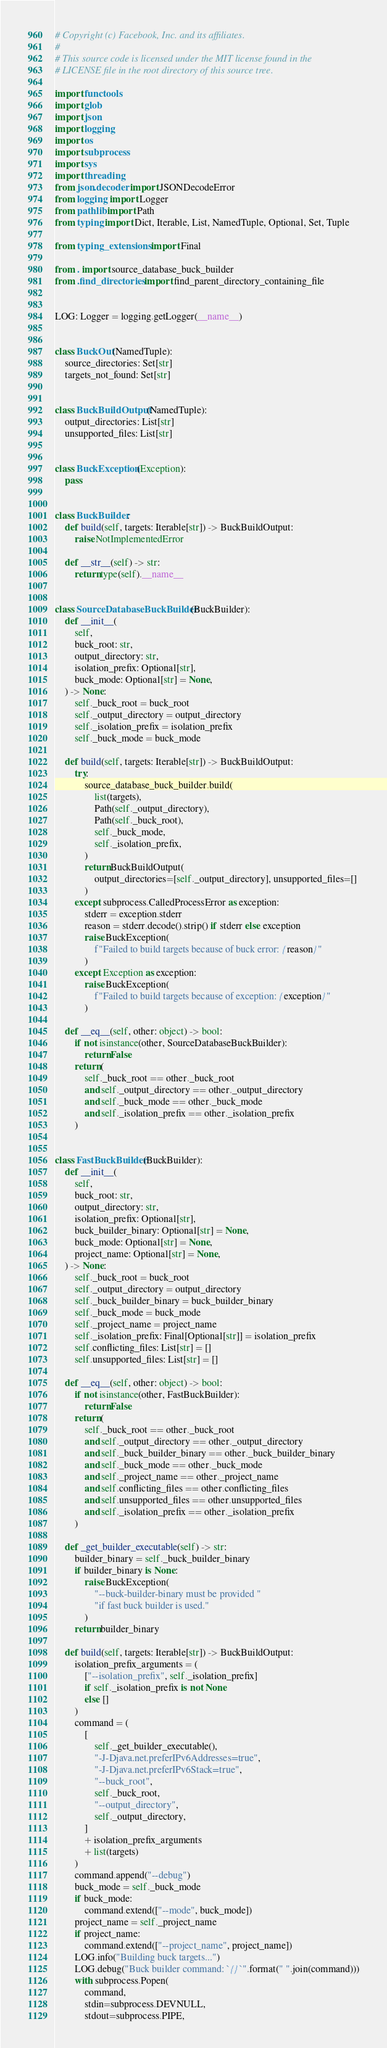<code> <loc_0><loc_0><loc_500><loc_500><_Python_># Copyright (c) Facebook, Inc. and its affiliates.
#
# This source code is licensed under the MIT license found in the
# LICENSE file in the root directory of this source tree.

import functools
import glob
import json
import logging
import os
import subprocess
import sys
import threading
from json.decoder import JSONDecodeError
from logging import Logger
from pathlib import Path
from typing import Dict, Iterable, List, NamedTuple, Optional, Set, Tuple

from typing_extensions import Final

from . import source_database_buck_builder
from .find_directories import find_parent_directory_containing_file


LOG: Logger = logging.getLogger(__name__)


class BuckOut(NamedTuple):
    source_directories: Set[str]
    targets_not_found: Set[str]


class BuckBuildOutput(NamedTuple):
    output_directories: List[str]
    unsupported_files: List[str]


class BuckException(Exception):
    pass


class BuckBuilder:
    def build(self, targets: Iterable[str]) -> BuckBuildOutput:
        raise NotImplementedError

    def __str__(self) -> str:
        return type(self).__name__


class SourceDatabaseBuckBuilder(BuckBuilder):
    def __init__(
        self,
        buck_root: str,
        output_directory: str,
        isolation_prefix: Optional[str],
        buck_mode: Optional[str] = None,
    ) -> None:
        self._buck_root = buck_root
        self._output_directory = output_directory
        self._isolation_prefix = isolation_prefix
        self._buck_mode = buck_mode

    def build(self, targets: Iterable[str]) -> BuckBuildOutput:
        try:
            source_database_buck_builder.build(
                list(targets),
                Path(self._output_directory),
                Path(self._buck_root),
                self._buck_mode,
                self._isolation_prefix,
            )
            return BuckBuildOutput(
                output_directories=[self._output_directory], unsupported_files=[]
            )
        except subprocess.CalledProcessError as exception:
            stderr = exception.stderr
            reason = stderr.decode().strip() if stderr else exception
            raise BuckException(
                f"Failed to build targets because of buck error: {reason}"
            )
        except Exception as exception:
            raise BuckException(
                f"Failed to build targets because of exception: {exception}"
            )

    def __eq__(self, other: object) -> bool:
        if not isinstance(other, SourceDatabaseBuckBuilder):
            return False
        return (
            self._buck_root == other._buck_root
            and self._output_directory == other._output_directory
            and self._buck_mode == other._buck_mode
            and self._isolation_prefix == other._isolation_prefix
        )


class FastBuckBuilder(BuckBuilder):
    def __init__(
        self,
        buck_root: str,
        output_directory: str,
        isolation_prefix: Optional[str],
        buck_builder_binary: Optional[str] = None,
        buck_mode: Optional[str] = None,
        project_name: Optional[str] = None,
    ) -> None:
        self._buck_root = buck_root
        self._output_directory = output_directory
        self._buck_builder_binary = buck_builder_binary
        self._buck_mode = buck_mode
        self._project_name = project_name
        self._isolation_prefix: Final[Optional[str]] = isolation_prefix
        self.conflicting_files: List[str] = []
        self.unsupported_files: List[str] = []

    def __eq__(self, other: object) -> bool:
        if not isinstance(other, FastBuckBuilder):
            return False
        return (
            self._buck_root == other._buck_root
            and self._output_directory == other._output_directory
            and self._buck_builder_binary == other._buck_builder_binary
            and self._buck_mode == other._buck_mode
            and self._project_name == other._project_name
            and self.conflicting_files == other.conflicting_files
            and self.unsupported_files == other.unsupported_files
            and self._isolation_prefix == other._isolation_prefix
        )

    def _get_builder_executable(self) -> str:
        builder_binary = self._buck_builder_binary
        if builder_binary is None:
            raise BuckException(
                "--buck-builder-binary must be provided "
                "if fast buck builder is used."
            )
        return builder_binary

    def build(self, targets: Iterable[str]) -> BuckBuildOutput:
        isolation_prefix_arguments = (
            ["--isolation_prefix", self._isolation_prefix]
            if self._isolation_prefix is not None
            else []
        )
        command = (
            [
                self._get_builder_executable(),
                "-J-Djava.net.preferIPv6Addresses=true",
                "-J-Djava.net.preferIPv6Stack=true",
                "--buck_root",
                self._buck_root,
                "--output_directory",
                self._output_directory,
            ]
            + isolation_prefix_arguments
            + list(targets)
        )
        command.append("--debug")
        buck_mode = self._buck_mode
        if buck_mode:
            command.extend(["--mode", buck_mode])
        project_name = self._project_name
        if project_name:
            command.extend(["--project_name", project_name])
        LOG.info("Building buck targets...")
        LOG.debug("Buck builder command: `{}`".format(" ".join(command)))
        with subprocess.Popen(
            command,
            stdin=subprocess.DEVNULL,
            stdout=subprocess.PIPE,</code> 